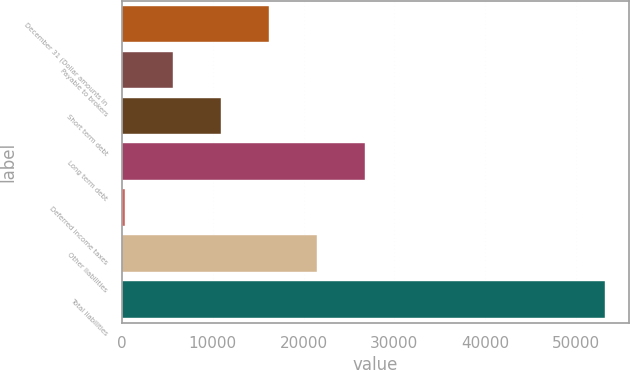<chart> <loc_0><loc_0><loc_500><loc_500><bar_chart><fcel>December 31 (Dollar amounts in<fcel>Payable to brokers<fcel>Short term debt<fcel>Long term debt<fcel>Deferred income taxes<fcel>Other liabilities<fcel>Total liabilities<nl><fcel>16233.1<fcel>5665.7<fcel>10949.4<fcel>26800.5<fcel>382<fcel>21516.8<fcel>53219<nl></chart> 